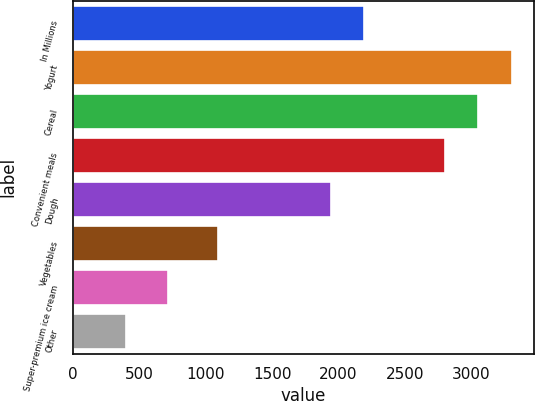Convert chart to OTSL. <chart><loc_0><loc_0><loc_500><loc_500><bar_chart><fcel>In Millions<fcel>Yogurt<fcel>Cereal<fcel>Convenient meals<fcel>Dough<fcel>Vegetables<fcel>Super-premium ice cream<fcel>Other<nl><fcel>2195.66<fcel>3304.82<fcel>3053.86<fcel>2802.9<fcel>1944.7<fcel>1089.5<fcel>717.1<fcel>398.8<nl></chart> 